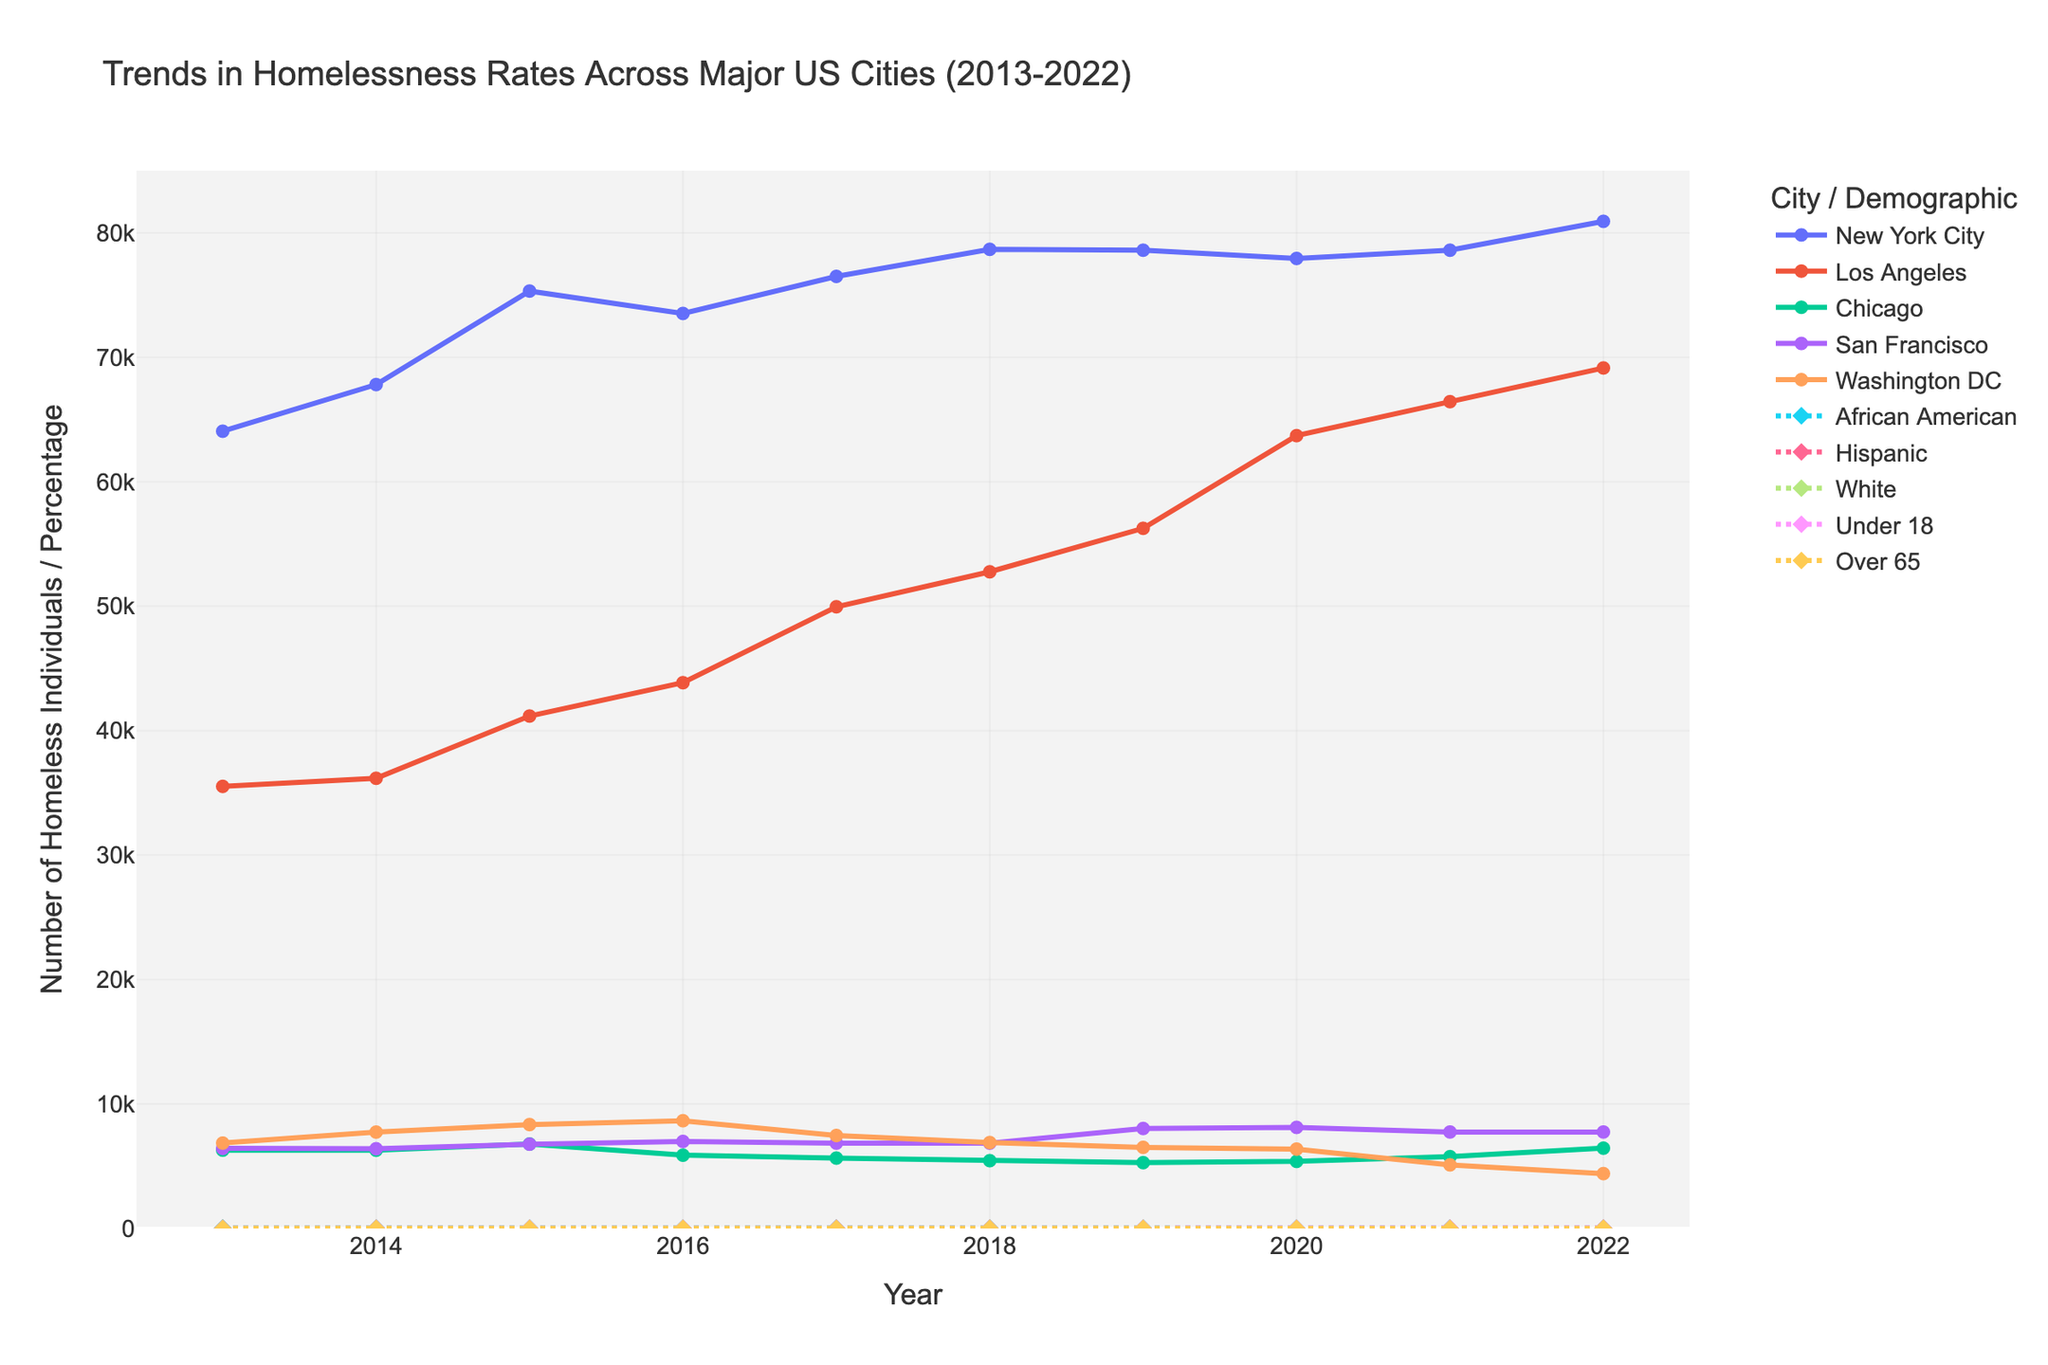Which city had the highest number of homeless individuals in 2022? Look at the lines representing cities in 2022. The line corresponding to New York City is the highest.
Answer: New York City What is the trend in homelessness rates for Los Angeles from 2013 to 2022? Observe the line for Los Angeles across the years. It shows a general upward trend, indicating an increase in homelessness.
Answer: Increasing Compare the rate of homelessness for the demographic group "Under 18" in 2013 and 2022. Look at the 'Under 18' data points for the years 2013 and 2022. These are 22.4 and 27.5, respectively. Observe that the value increased from 2013 to 2022.
Answer: Increased Which demographic had the lowest rate of homelessness in 2022? Examine the lines for the demographic groups in 2022. The line for "Over 65" is the lowest at that point.
Answer: Over 65 What is the change in the number of homeless individuals in New York City between 2019 and 2022? Look at New York City's values for 2019 (78,604) and 2022 (80,926). Subtract the 2019 value from the 2022 value: 80,926 - 78,604 = 2,322.
Answer: 2,322 How does the homelessness trend for Chicago compare to that of San Francisco from 2018 to 2022? Compare the lines for Chicago and San Francisco between 2018 and 2022. Chicago shows a downward trend while San Francisco shows an approximately steady trend.
Answer: Chicago decreased, San Francisco steady What is the average rate of homelessness for the Hispanic demographic from 2015 to 2022? Average the Hispanic values from 2015 to 2022: (22.8 + 23.1 + 23.7 + 24.2 + 24.7 + 25.3 + 25.8 + 26.2) / 8. The result is approximately 24.73.
Answer: 24.73 Which demographic saw the most significant percentage increase in homelessness rates from 2013 to 2022? Compare the percentage change for each demographic by finding the difference between their 2013 and 2022 values and then comparing them. "Over 65" increased from 4.9 to 7.6, a notable increase.
Answer: Over 65 How many more homeless individuals were there in Los Angeles compared to Washington D.C. in 2020? Look at the values for Los Angeles and Washington D.C. in 2020. Los Angeles has 63,706, and Washington D.C. has 6,380. The difference is 63,706 - 6,380 = 57,326.
Answer: 57,326 What is the combined rate of homelessness for "White" and "African American" demographics in 2022? Add the values for "White" and "African American" in 2022. "White" is 34.0, and "African American" is 38.7. The combined rate is 34.0 + 38.7 = 72.7.
Answer: 72.7 